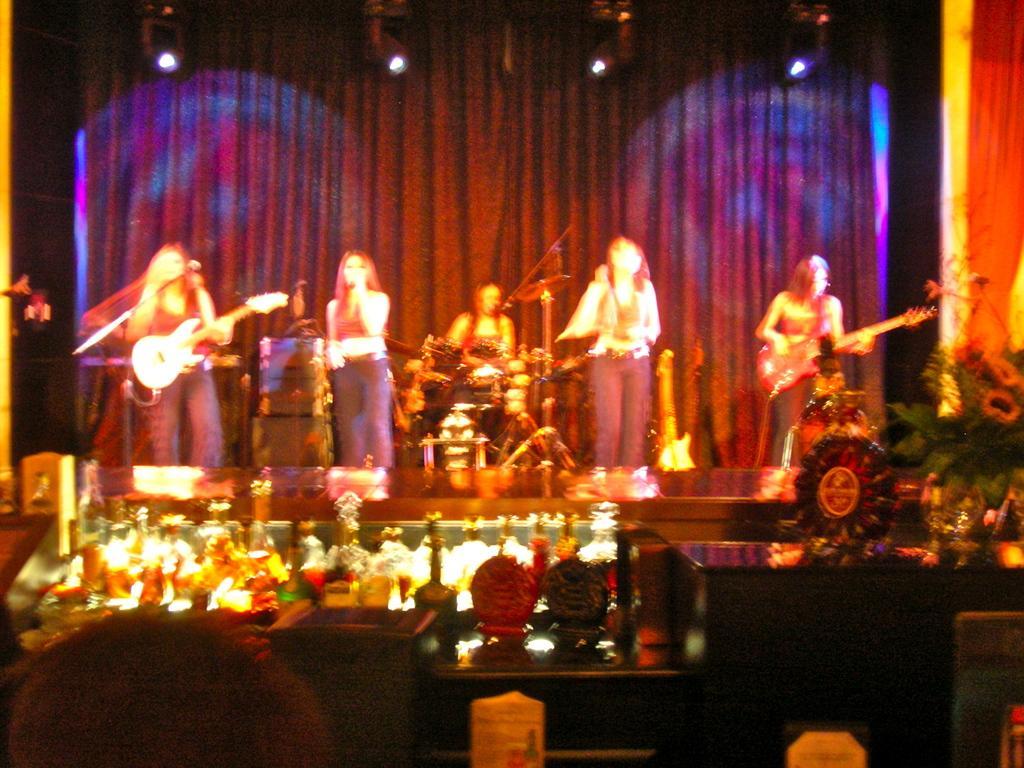Could you give a brief overview of what you see in this image? In this picture we can see a group of women performing on the stage with different musical instruments. In the background, we can see lights and curtains. In the foreground we can see people on chairs near the tables. Here we can see glasses, flower pots etc., 